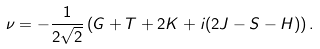Convert formula to latex. <formula><loc_0><loc_0><loc_500><loc_500>\nu = - \frac { 1 } { 2 \sqrt { 2 } } \left ( G + T + 2 K + i ( 2 J - S - H ) \right ) .</formula> 